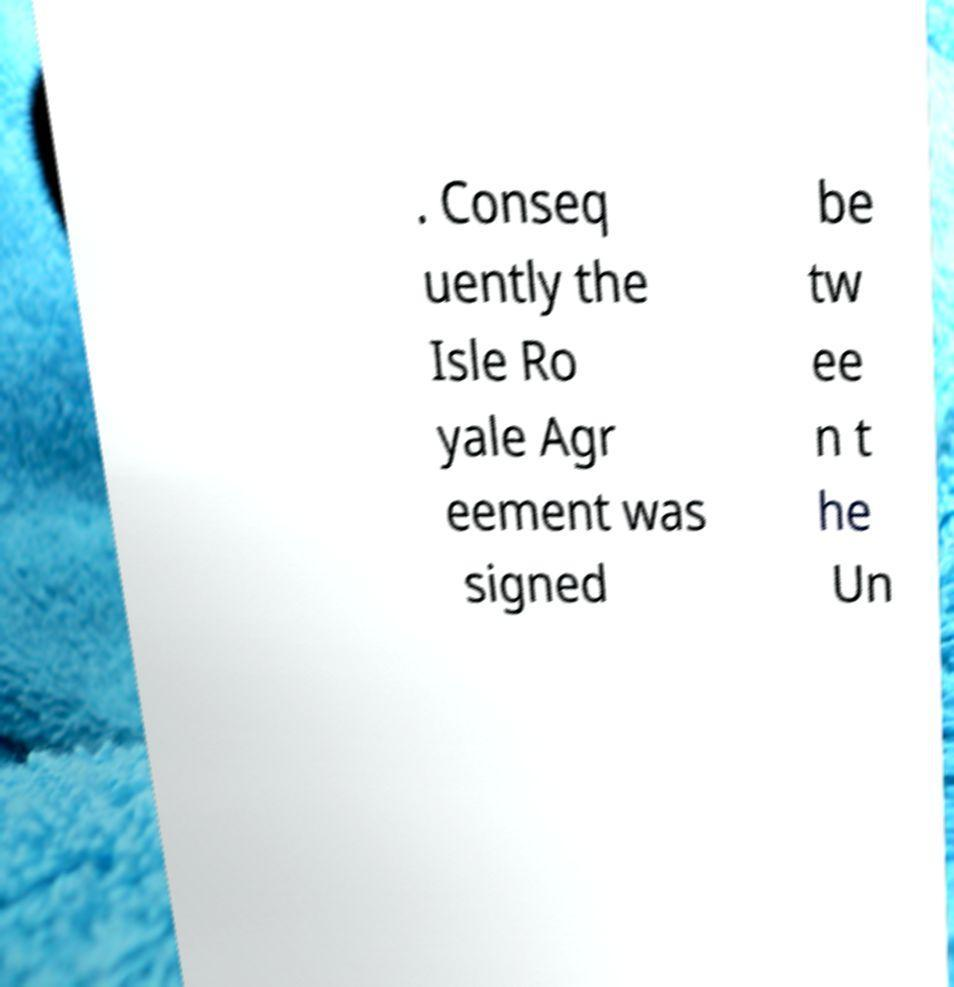Please identify and transcribe the text found in this image. . Conseq uently the Isle Ro yale Agr eement was signed be tw ee n t he Un 